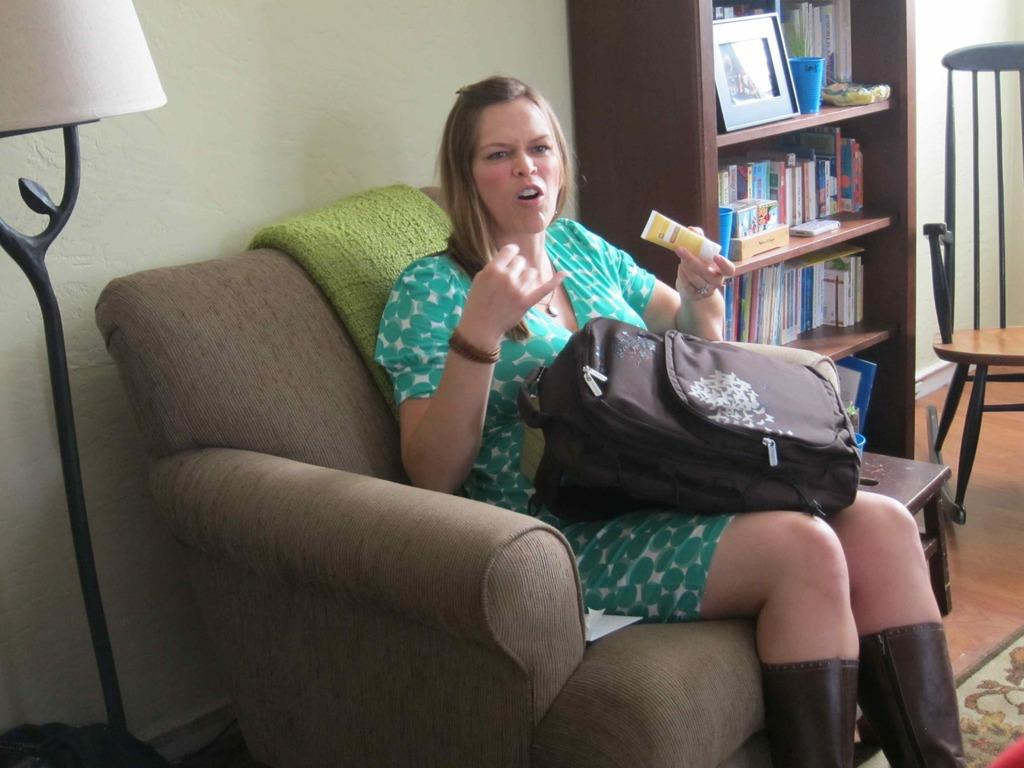Who is the main subject in the image? There is a woman in the image. What is the woman doing in the image? The woman is sitting on a chair. Does the woman have any belongings with her? Yes, the woman has a bag on her. What else can be seen in the image? There is a rack of books present in the image. How many brothers does the woman have in the image? There is no information about the woman's brothers in the image. What type of tank is visible in the image? There is no tank present in the image. 